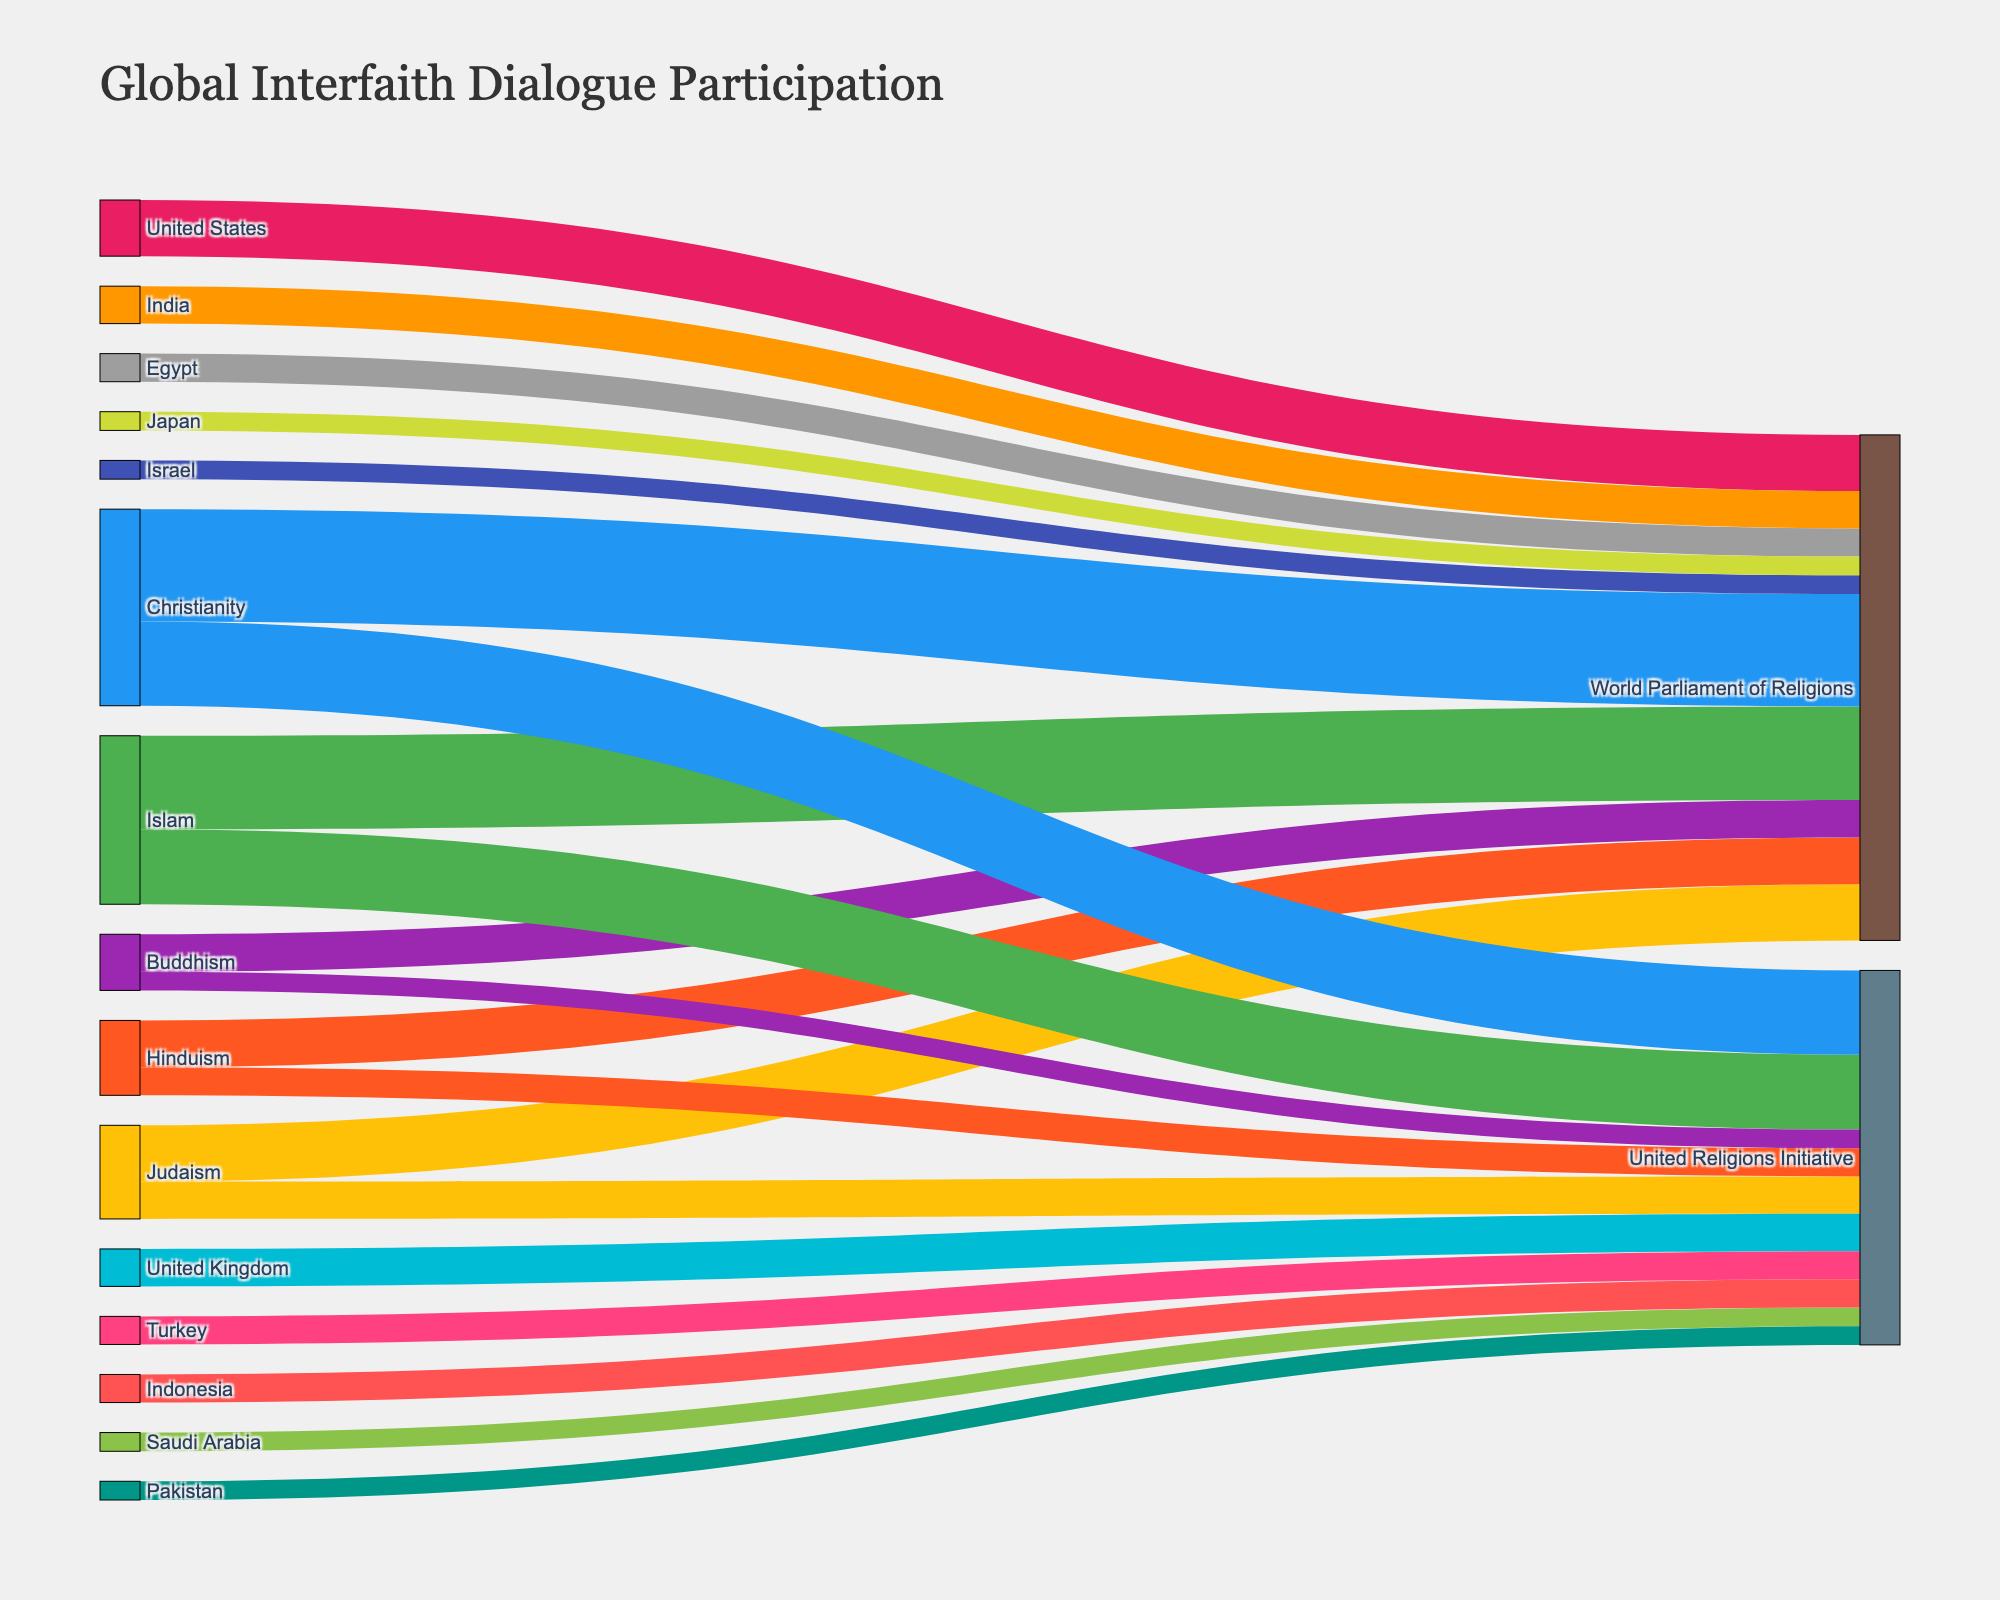What's the title of the figure? The title is displayed at the top of the figure and is clearly readable as "Global Interfaith Dialogue Participation"
Answer: Global Interfaith Dialogue Participation Which religious group has the highest participation in the World Parliament of Religions? By looking at the links connecting religious groups to the World Parliament of Religions, the width of the flow from Christianity is the widest, indicating the highest value.
Answer: Christianity What is the total number of participants in the United Religions Initiative from all religious groups? Sum the values of all flows directed towards the United Religions Initiative, which are 400 (Islam) + 450 (Christianity) + 200 (Judaism) + 150 (Hinduism) + 100 (Buddhism). The total is 1300.
Answer: 1300 How does the participation from Hinduism in both organizations compare? Compare the heights of the Hinduism flows to both organizations. Hinduism has 250 participants in the World Parliament of Religions and 150 in the United Religions Initiative, so there are more participants in the former.
Answer: Hinduism has more participation in the World Parliament of Religions Which country has the highest participation in the World Parliament of Religions? By observing the connections from countries to the World Parliament of Religions, the widest flow comes from the United States, indicating the highest value.
Answer: United States How many more participants does Islam have in World Parliament of Religions compared to Buddhism in the same organization? Subtract the number of participants in Buddhism (200) from those in Islam (500). The result is 500 - 200 = 300.
Answer: 300 Compare the total number of participants from religious groups in the World Parliament of Religions to the United Religions Initiative. Sum the values for all religious groups participating in each organization and compare. The World Parliament of Religions has 500 (Islam) + 600 (Christianity) + 300 (Judaism) + 250 (Hinduism) + 200 (Buddhism) = 1850. The United Religions Initiative has 1300. Thus, the World Parliament has more participants.
Answer: World Parliament of Religions has more participants Which country contributes the least to the United Religions Initiative? By observing the flows from different countries to the United Religions Initiative, the smallest flow is from Pakistan with a value of 100.
Answer: Pakistan What is the ratio of Christianity's participation to that of Judaism in the World Parliament of Religions? Divide Christianity's participants (600) by Judaism's participants (300). The ratio is 600/300 = 2.
Answer: 2 How many total flows are there from religions to the two interfaith organizations? Count the number of connections from religious groups to both the World Parliament of Religions and the United Religions Initiative. There are 5 (Islam, Christianity, Judaism, Hinduism, Buddhism) flows to World Parliament and 5 to United Religions Initiative, making a total of 10 flows.
Answer: 10 